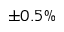<formula> <loc_0><loc_0><loc_500><loc_500>\pm 0 . 5 \%</formula> 